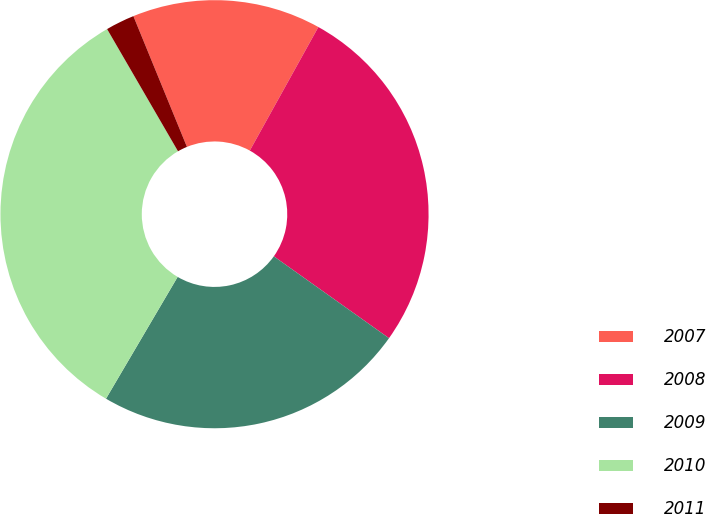Convert chart to OTSL. <chart><loc_0><loc_0><loc_500><loc_500><pie_chart><fcel>2007<fcel>2008<fcel>2009<fcel>2010<fcel>2011<nl><fcel>14.25%<fcel>26.77%<fcel>23.63%<fcel>33.17%<fcel>2.18%<nl></chart> 